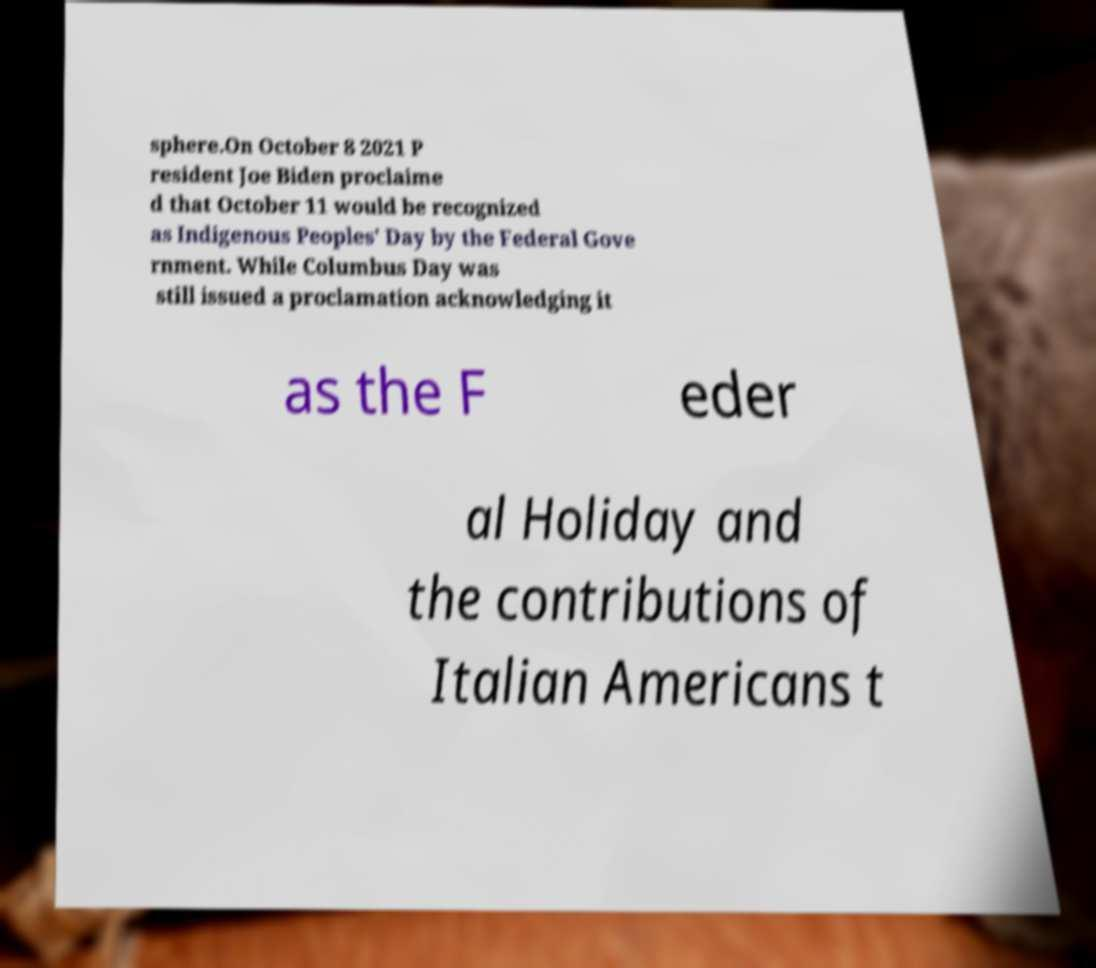Could you extract and type out the text from this image? sphere.On October 8 2021 P resident Joe Biden proclaime d that October 11 would be recognized as Indigenous Peoples' Day by the Federal Gove rnment. While Columbus Day was still issued a proclamation acknowledging it as the F eder al Holiday and the contributions of Italian Americans t 